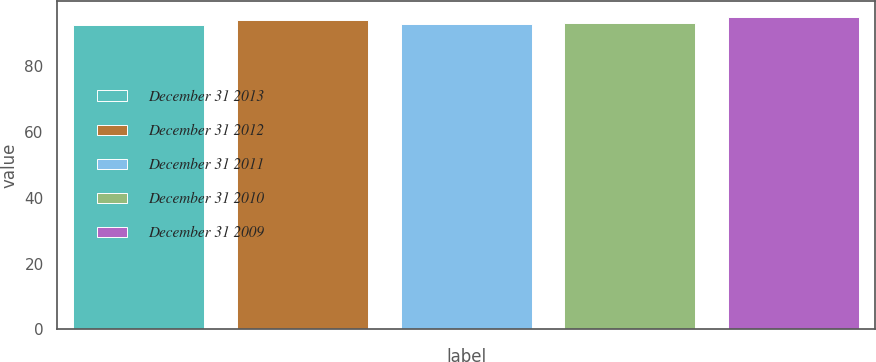Convert chart to OTSL. <chart><loc_0><loc_0><loc_500><loc_500><bar_chart><fcel>December 31 2013<fcel>December 31 2012<fcel>December 31 2011<fcel>December 31 2010<fcel>December 31 2009<nl><fcel>92.5<fcel>94.1<fcel>92.75<fcel>93<fcel>95<nl></chart> 